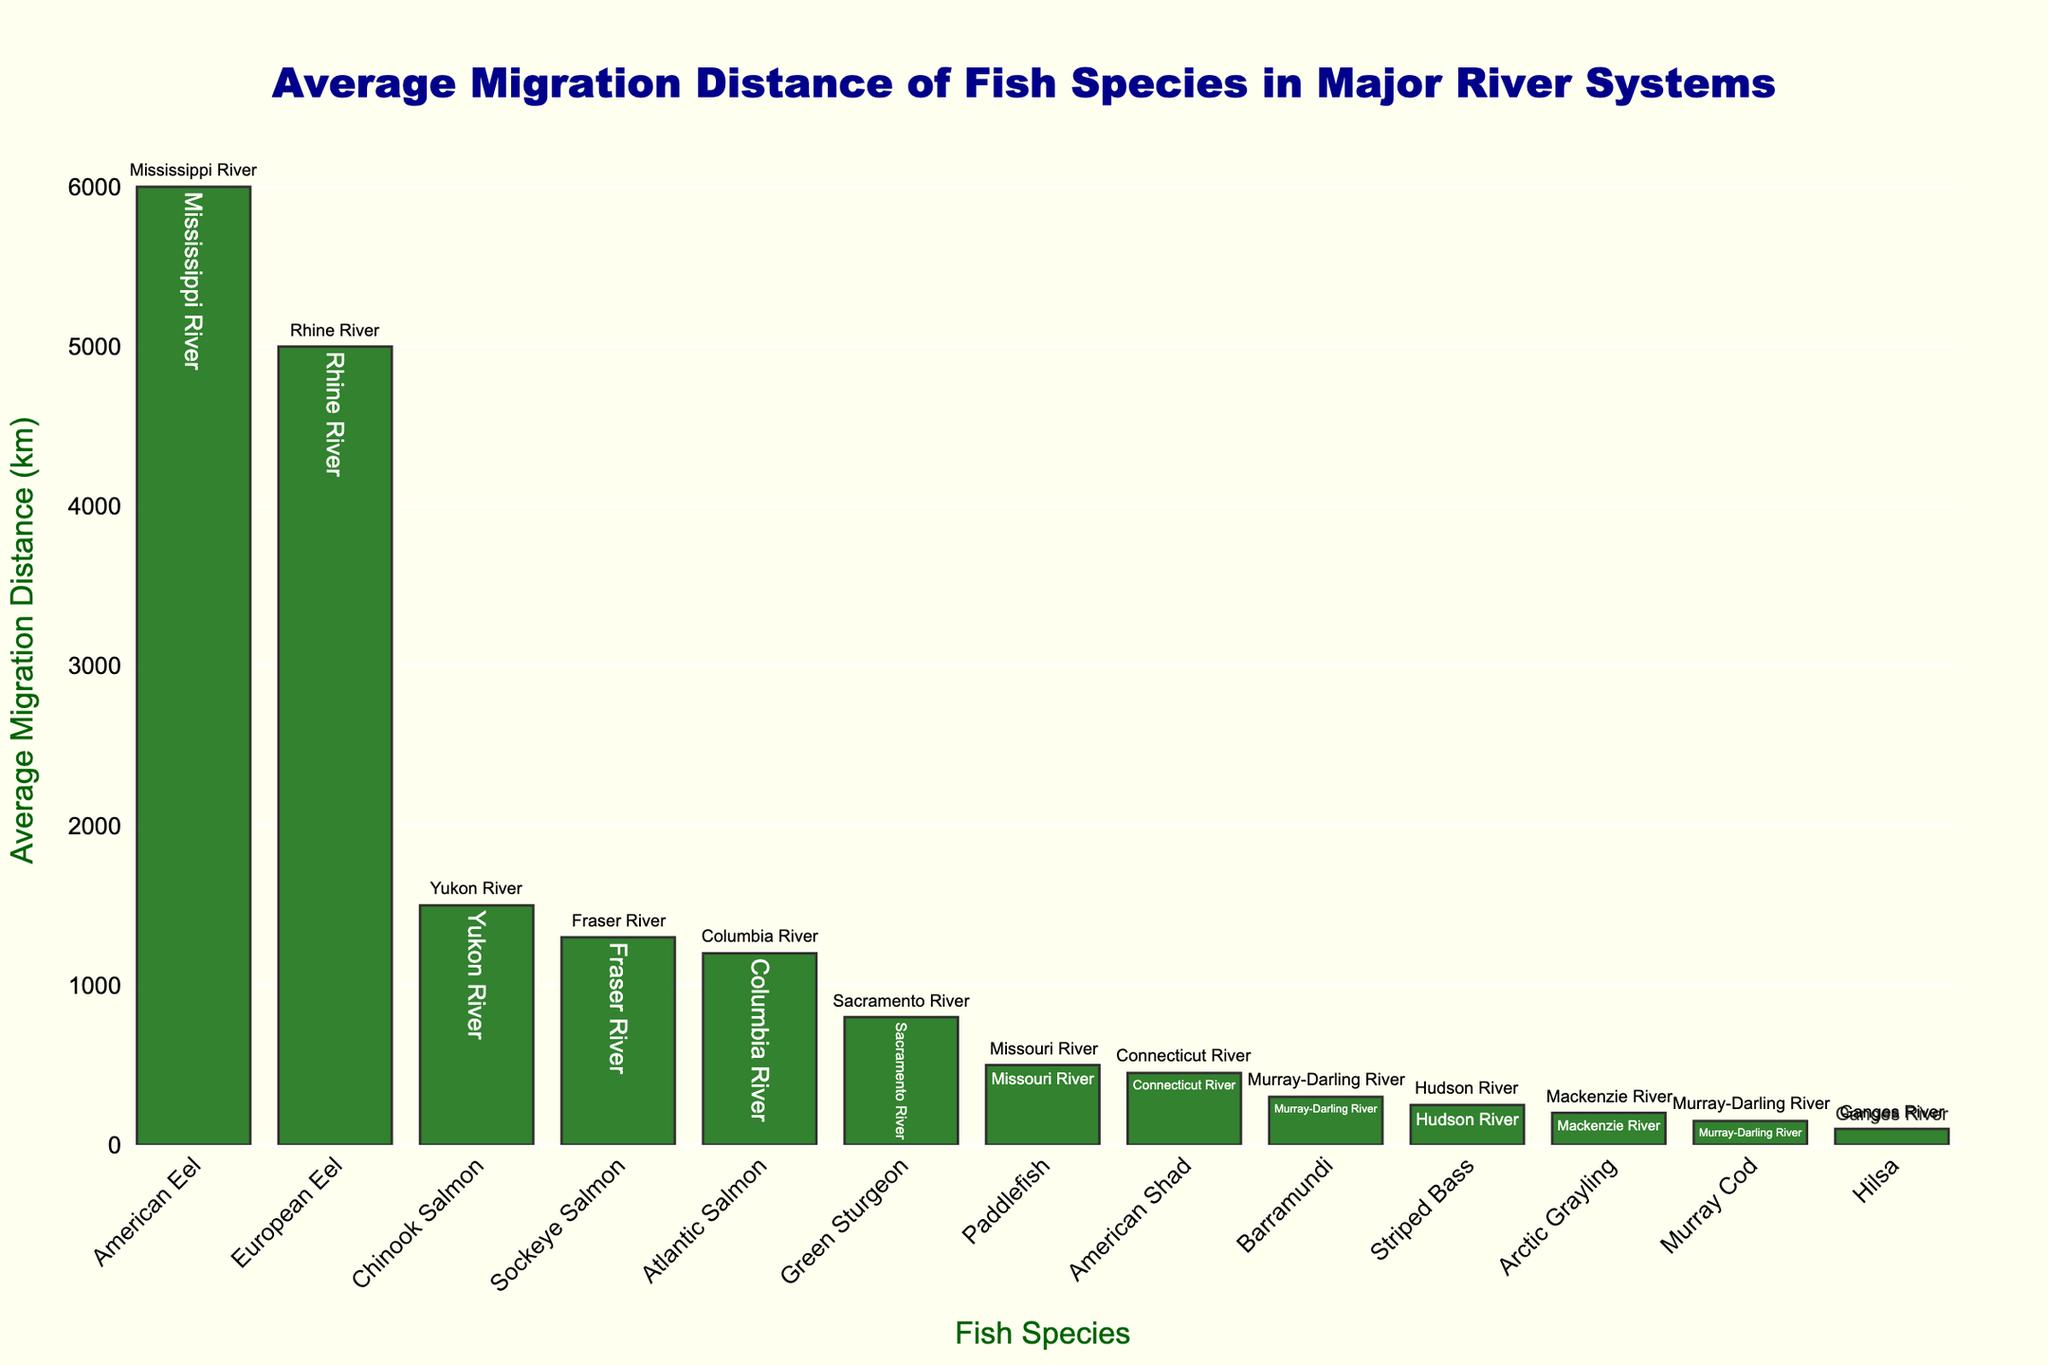What is the total average migration distance for Atlantic Salmon, American Eel, and Chinook Salmon? First, find the average migration distances for each of the specified species: Atlantic Salmon (1200 km), American Eel (6000 km), and Chinook Salmon (1500 km). Then sum these values: 1200 + 6000 + 1500 = 8700 km.
Answer: 8700 km Which species has a longer migration distance, Green Sturgeon or Paddlefish? Compare the average migration distances of Green Sturgeon (800 km) and Paddlefish (500 km). 800 km is greater than 500 km, thus Green Sturgeon has a longer migration distance.
Answer: Green Sturgeon What is the median migration distance of the fish species displayed in the figure? Arrange the migration distances in ascending order: 100, 150, 200, 250, 300, 450, 500, 800, 1200, 1300, 1500, 5000, 6000. The median is the middle value or the average of the two middle values in an ordered list. Here, the two middle values are 500 and 800, so the median is (500 + 800) / 2 = 650 km.
Answer: 650 km Which species has the shortest average migration distance and what river system is it associated with? Identify the species with the shortest bar, which is Hilsa with an average migration distance of 100 km. The river system associated with Hilsa is the Ganges River.
Answer: Hilsa, Ganges River How many species have an average migration distance greater than 1000 km? Count the number of species with bars higher than 1000 km: Atlantic Salmon, American Eel, Chinook Salmon, European Eel, and Sockeye Salmon. There are 5 species.
Answer: 5 What is the difference in migration distance between American Shad and Striped Bass? Find the average migration distances for American Shad (450 km) and Striped Bass (250 km). Subtract the smaller distance from the larger distance: 450 - 250 = 200 km.
Answer: 200 km Are there more species with a migration distance less than 500 km or greater than 500 km? Count the species with migration distances less than 500 km (Arctic Grayling, Hilsa, Murray Cod, Barramundi, Striped Bass, American Shad) and those with distances greater than 500 km (Paddlefish, Green Sturgeon, Atlantic Salmon, American Eel, Chinook Salmon, European Eel, Sockeye Salmon). There are 6 species less than 500 km and 7 species greater than 500 km.
Answer: Greater than 500 km What is the average migration distance of the salmon species in the figure? Identify the salmon species and their distances: Atlantic Salmon (1200 km), Chinook Salmon (1500 km), Sockeye Salmon (1300 km). Sum these distances: 1200 + 1500 + 1300 = 4000 km, and divide by the number of salmon species (3). 4000 / 3 ≈ 1333.33 km.
Answer: 1333.33 km Which fish species is associated with the Fraser River and what is its migration distance? Identify the species associated with the Fraser River by reading the text annotations next to each bar. Sockeye Salmon is associated with the Fraser River, with a migration distance of 1300 km.
Answer: Sockeye Salmon, 1300 km If the average migration distance of Green Sturgeon is increased by 200 km, what would be its new migration distance and how would it rank among the other species? Green Sturgeon's current distance is 800 km. Increasing it by 200 km gives 800 + 200 = 1000 km. Then compare 1000 km with other distances: it places after Sockeye Salmon (1300 km) and before Paddlefish (500 km).
Answer: 1000 km, ranking below Sockeye Salmon 